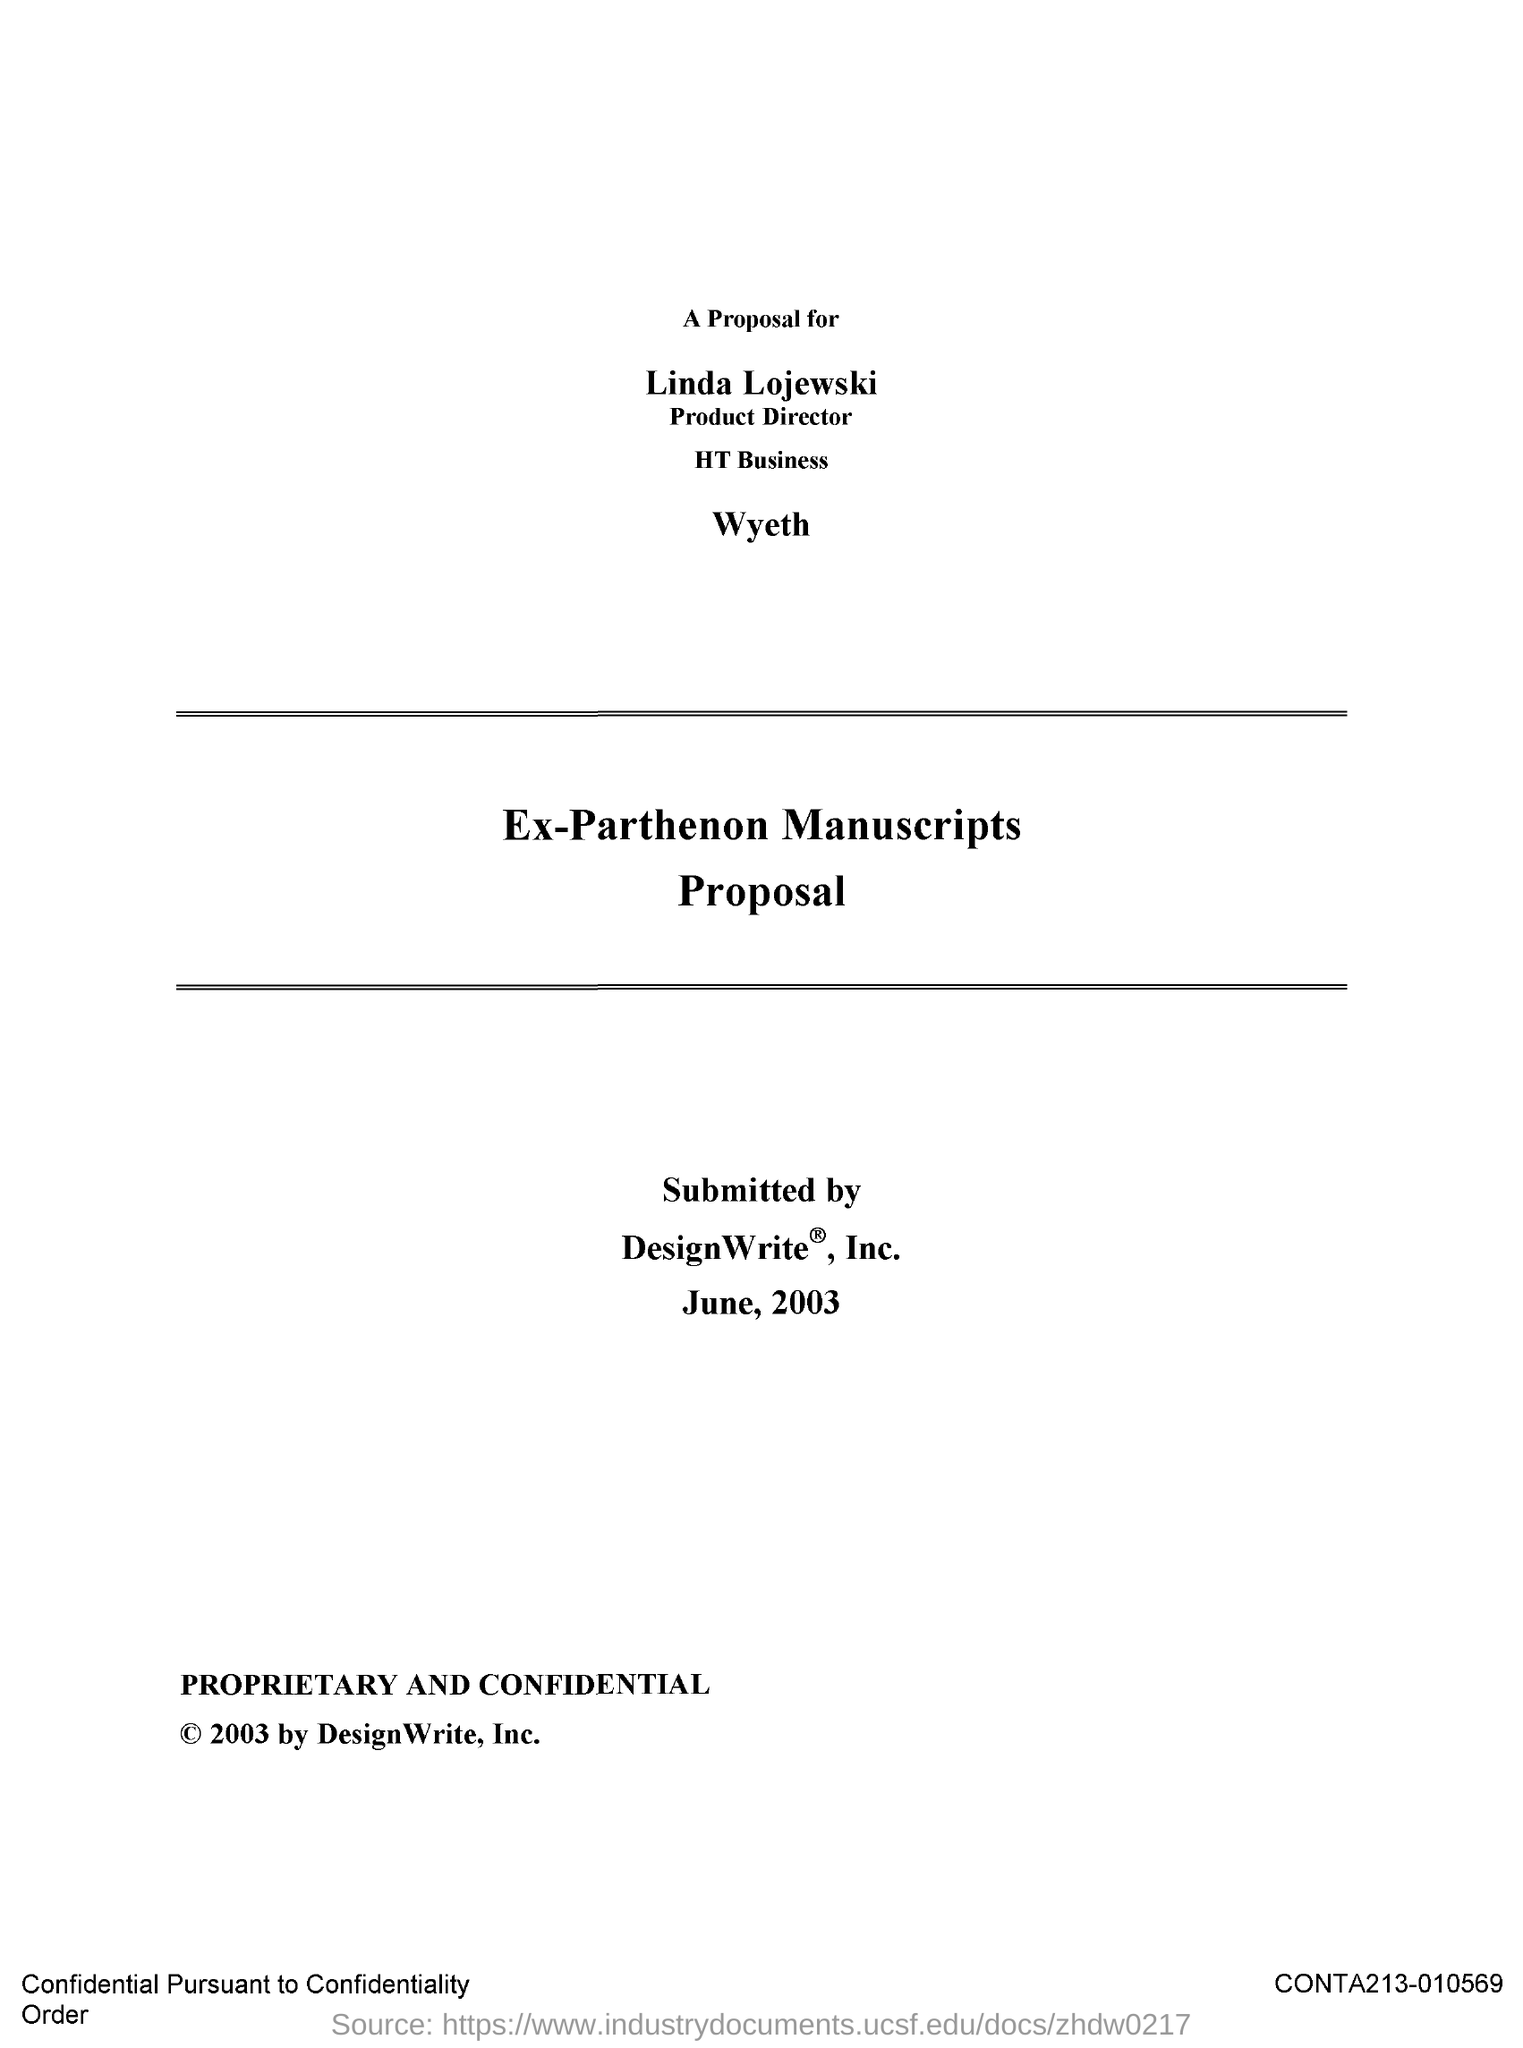Who is the Proposal for?
Ensure brevity in your answer.  Linda Lojewski. Who is this proposal presented to?
Your answer should be compact. Product Director. Who is it submitted by?
Your response must be concise. DesignWrite, Inc. When is it submitted?
Offer a very short reply. June, 2003. 